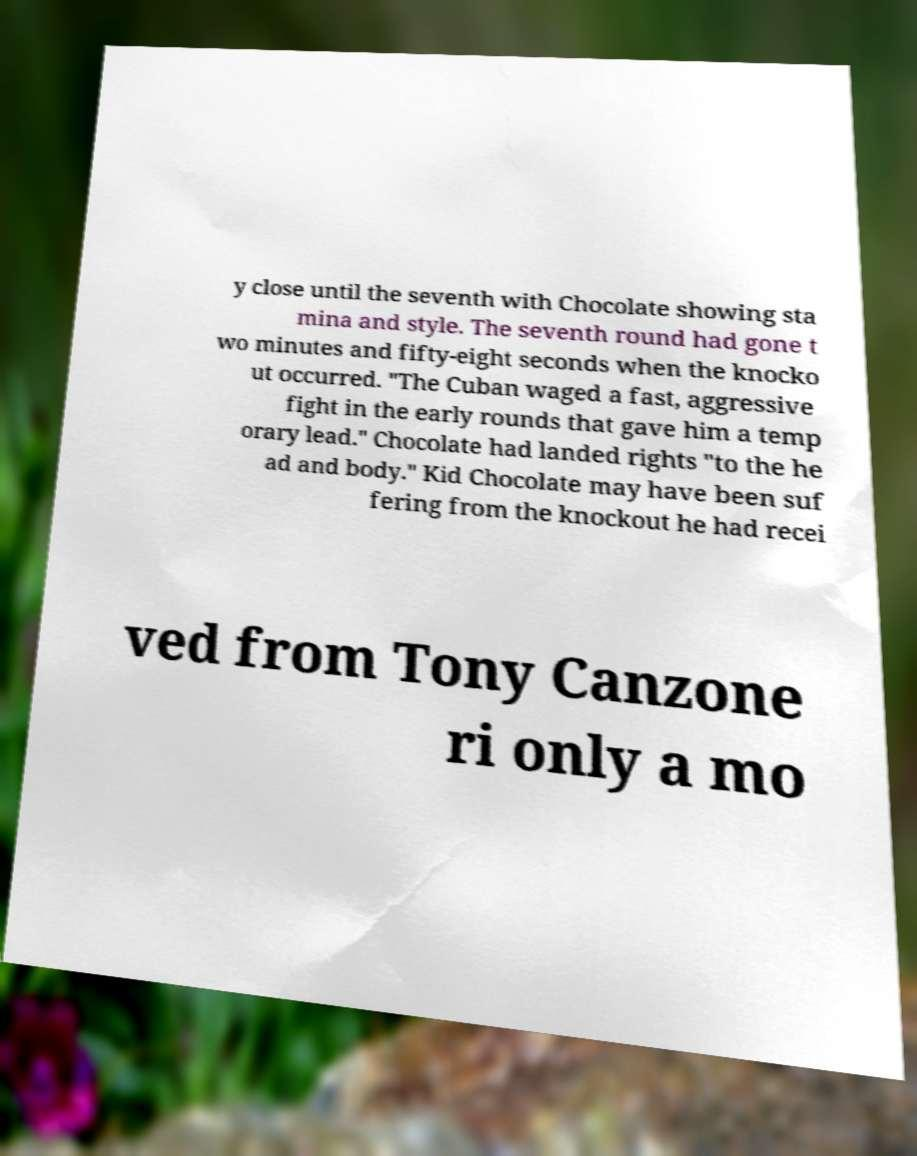Can you read and provide the text displayed in the image?This photo seems to have some interesting text. Can you extract and type it out for me? y close until the seventh with Chocolate showing sta mina and style. The seventh round had gone t wo minutes and fifty-eight seconds when the knocko ut occurred. "The Cuban waged a fast, aggressive fight in the early rounds that gave him a temp orary lead." Chocolate had landed rights "to the he ad and body." Kid Chocolate may have been suf fering from the knockout he had recei ved from Tony Canzone ri only a mo 